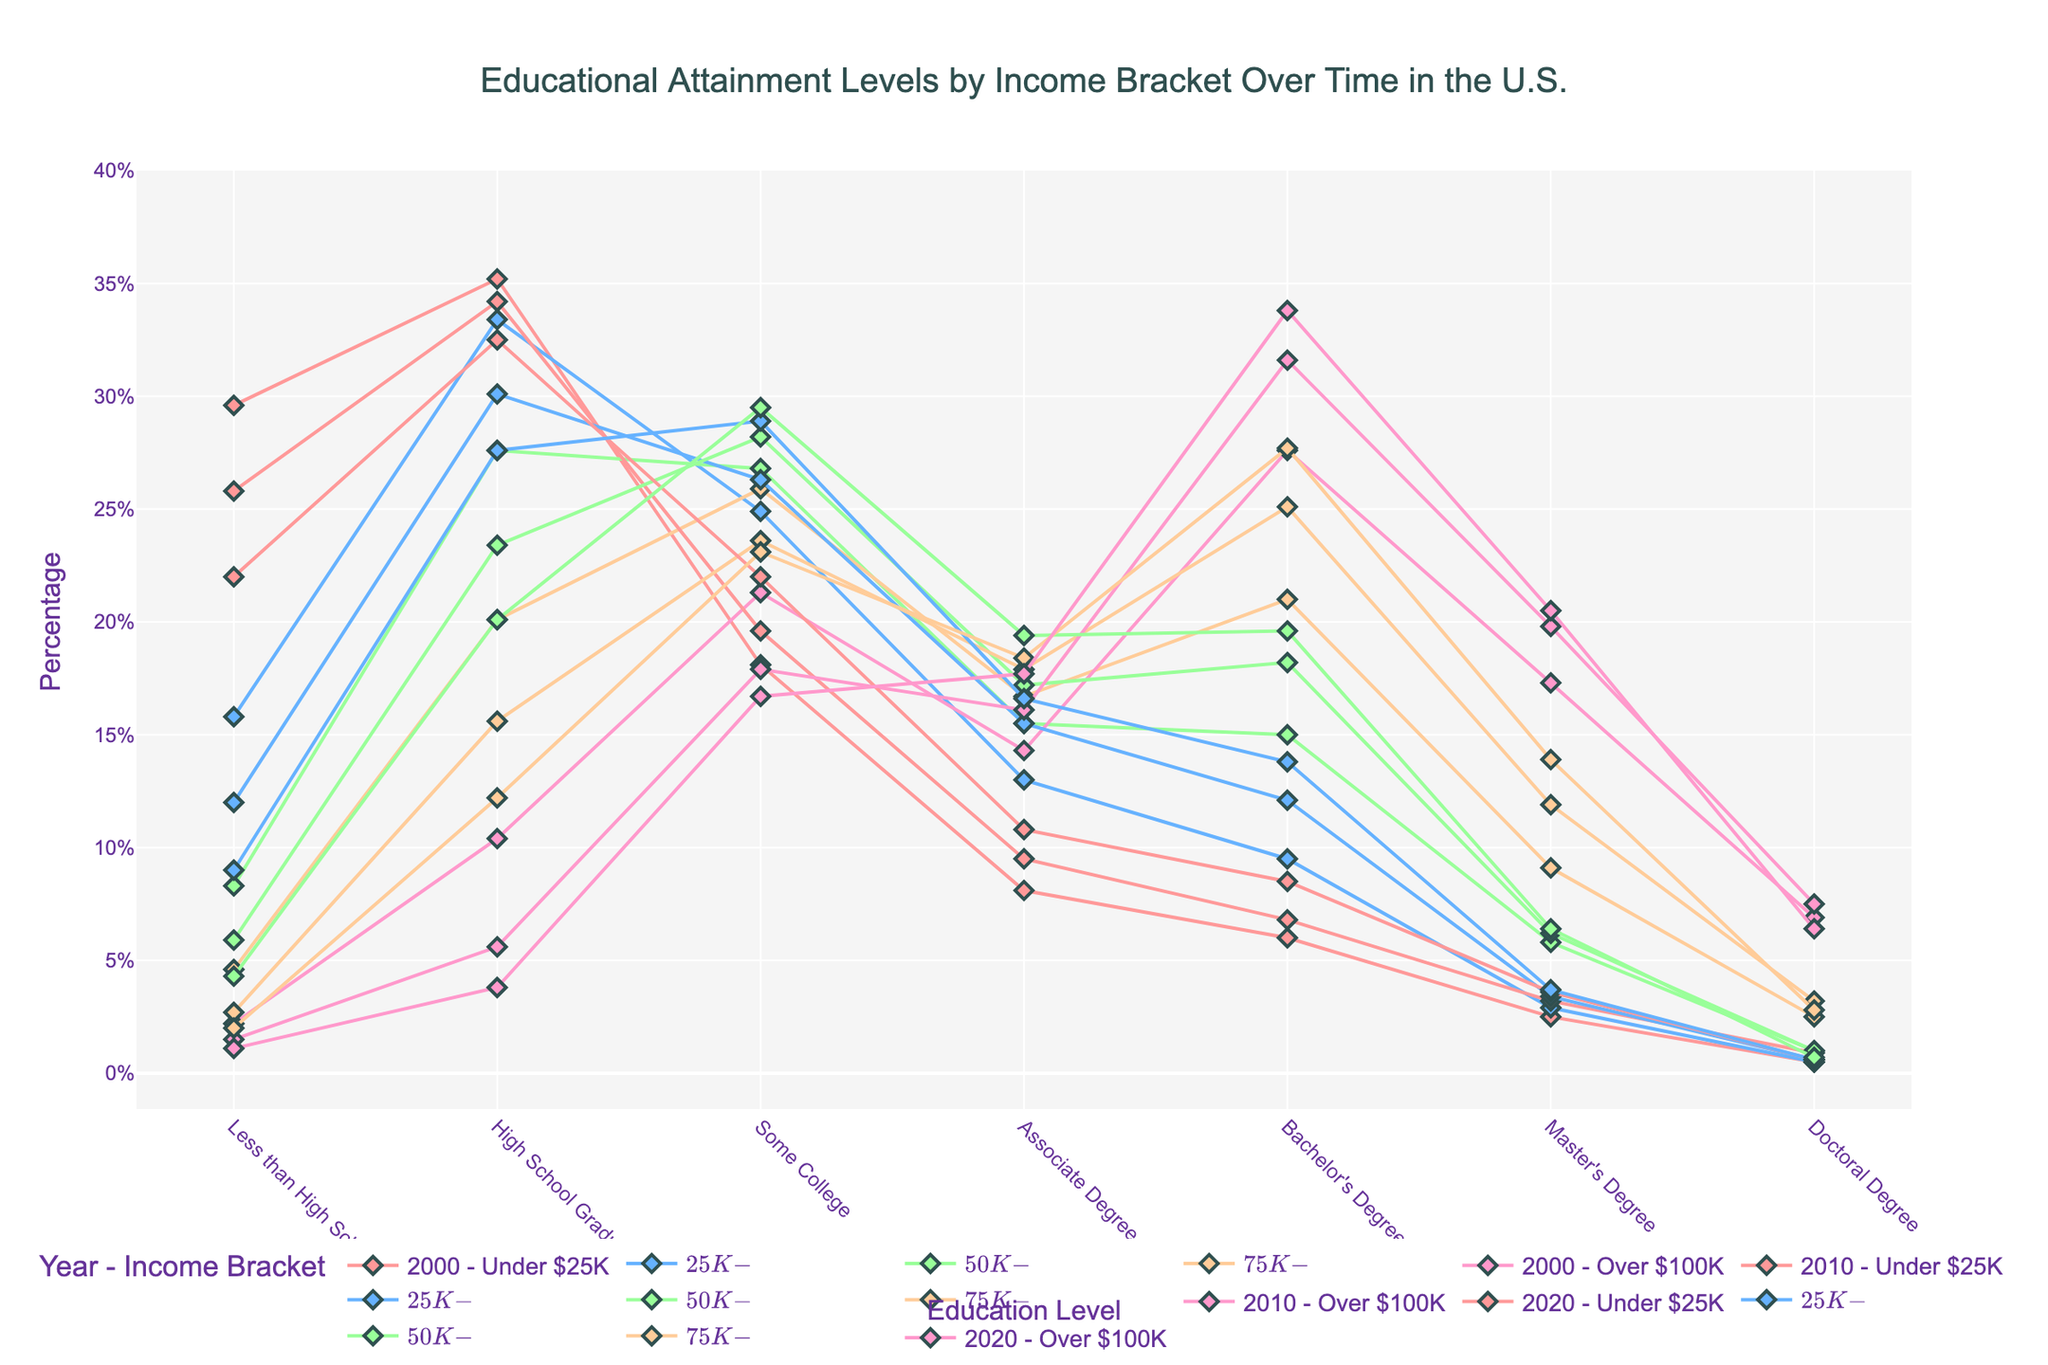What is the title of the figure? The title is displayed at the top center of the figure in larger font. It reads, "Educational Attainment Levels by Income Bracket Over Time in the U.S."
Answer: Educational Attainment Levels by Income Bracket Over Time in the U.S What is the percentage of people with a Bachelor’s Degree in the income bracket "$50K-$75K" in the year 2020? Look for the 2020 data specific to the "$50K-$75K" income bracket and find the percentage for the Bachelor's Degree category.
Answer: 19.6% Which year shows the highest percentage of people with a Doctoral Degree under the income bracket "Over $100K"? Check each yearly dataset for the income bracket "Over $100K" and compare the percentages for Doctoral Degrees.
Answer: 2010 How has the percentage of High School Graduates in the "Under $25K" income bracket changed from 2000 to 2020? Look at the percentages for High School Graduates in the "Under $25K" income bracket for the years 2000 and 2020, then calculate the difference.
Answer: From 35.2% to 32.5%, a decrease of 2.7% Which income bracket saw the largest increase in the percentage of people with Bachelor's Degrees from 2000 to 2020? Compare the Bachelor's Degree percentages for each income bracket between 2000 and 2020, and find the one with the largest increase.
Answer: Over $100K How do the percentages for people with Some College education in 2010 compare across different income brackets? Look at the "Some College" percentages for 2010 across all income brackets and list them for comparison.
Answer: Under $25K: 19.6%, $25K-$50K: 26.3%, $50K-$75K: 28.2%, $75K-$100K: 23.6%, Over $100K: 17.9% Which income bracket had the highest percentage of people with less than a High School education in 2000? Identify the "Less than High School" percentages for each income bracket in 2000 and determine which one is the highest.
Answer: Under $25K What is the general trend in educational attainment levels for the "Over $100K" income bracket from 2000 to 2020? Examine the data for each educational attainment level in the "Over $100K" income bracket across 2000, 2010, and 2020 to identify the overall trends and changes.
Answer: Increasing in higher education levels (Bachelor’s and above) For the year 2020, which income bracket had the lowest percentage of people with a Master's Degree? Check the percentage values for Master's Degree across all income brackets for 2020 and identify the lowest one.
Answer: Under $25K Compare the changes in the percentage of High School Graduates between "Under $25K" and "$25K-$50K" income brackets from 2000 to 2020. Look at the percentages of High School Graduates for "Under $25K" and "$25K-$50K" in 2000 and 2020, then compare the changes between the two income brackets.
Answer: Under $25K: Decreased from 35.2% to 32.5%; $25K-$50K: Decreased from 33.4% to 27.6% 